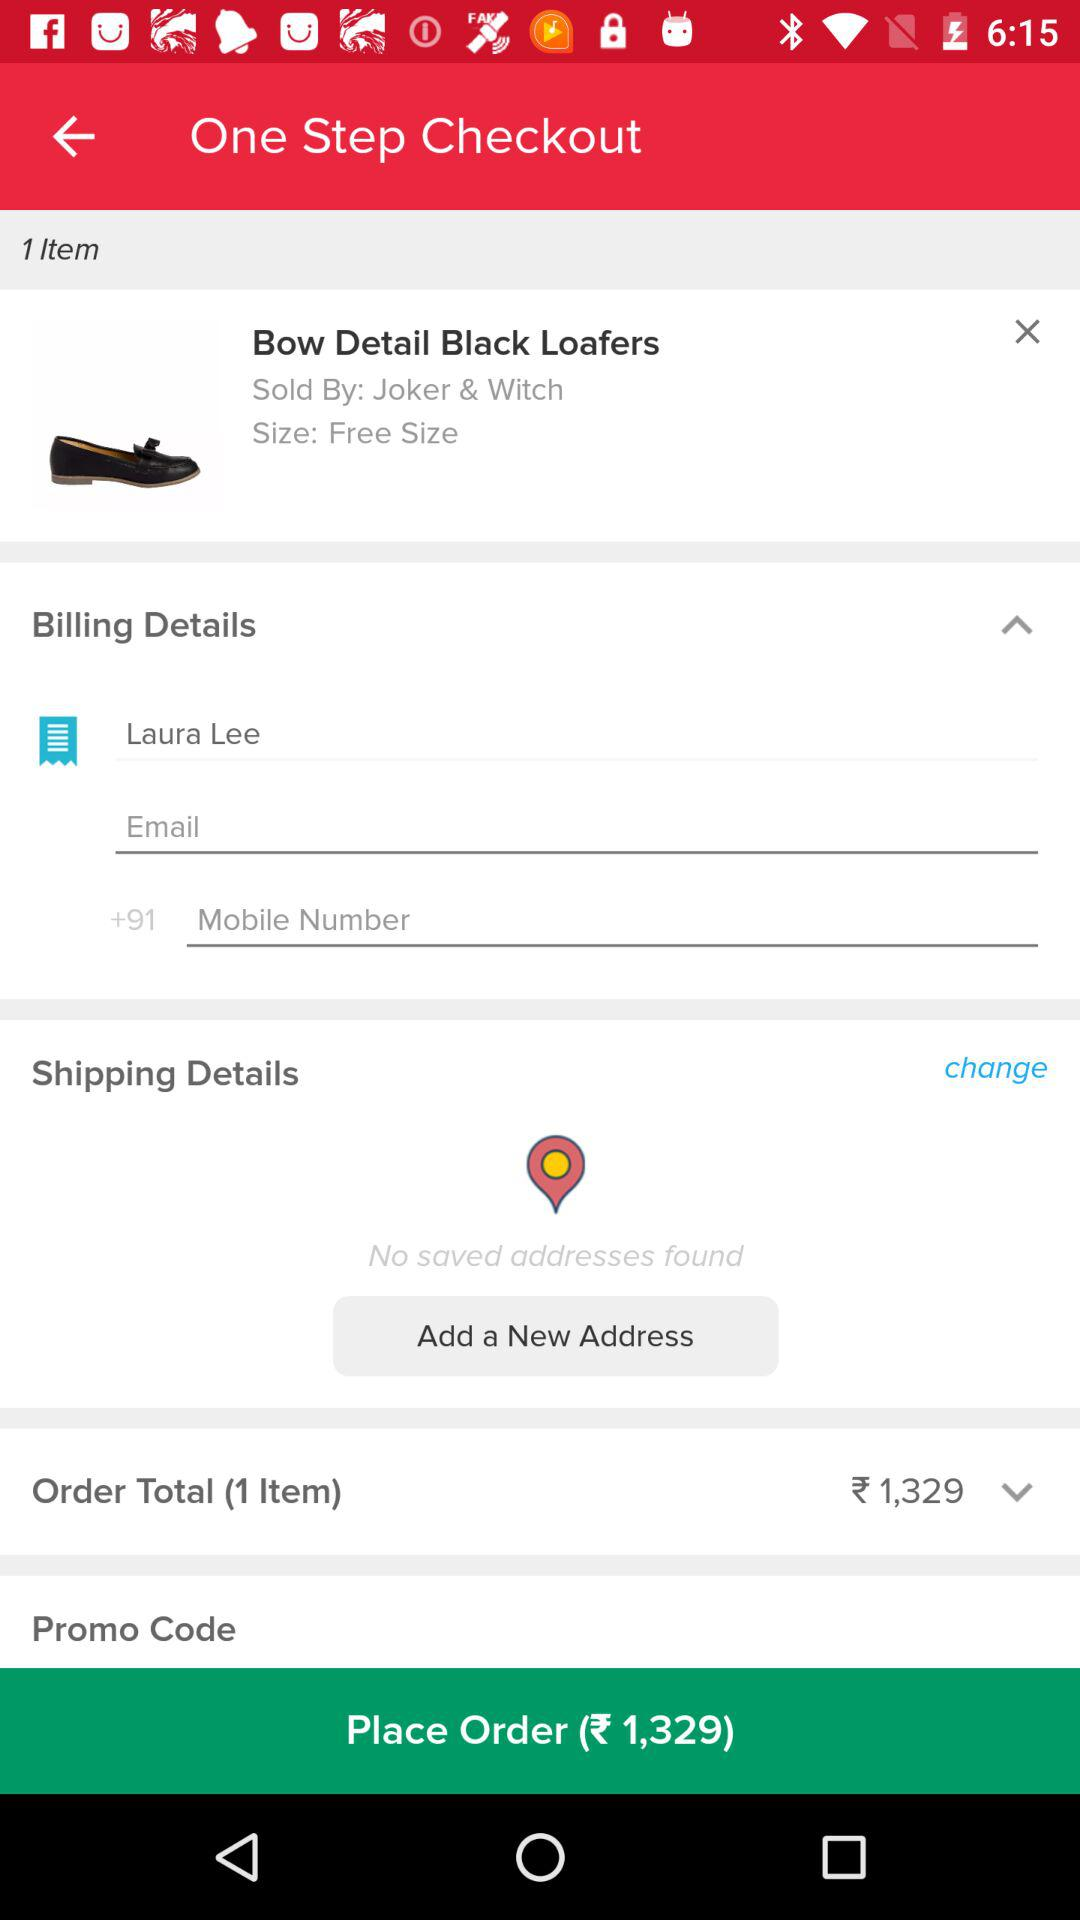Where will the order be shipped?
When the provided information is insufficient, respond with <no answer>. <no answer> 